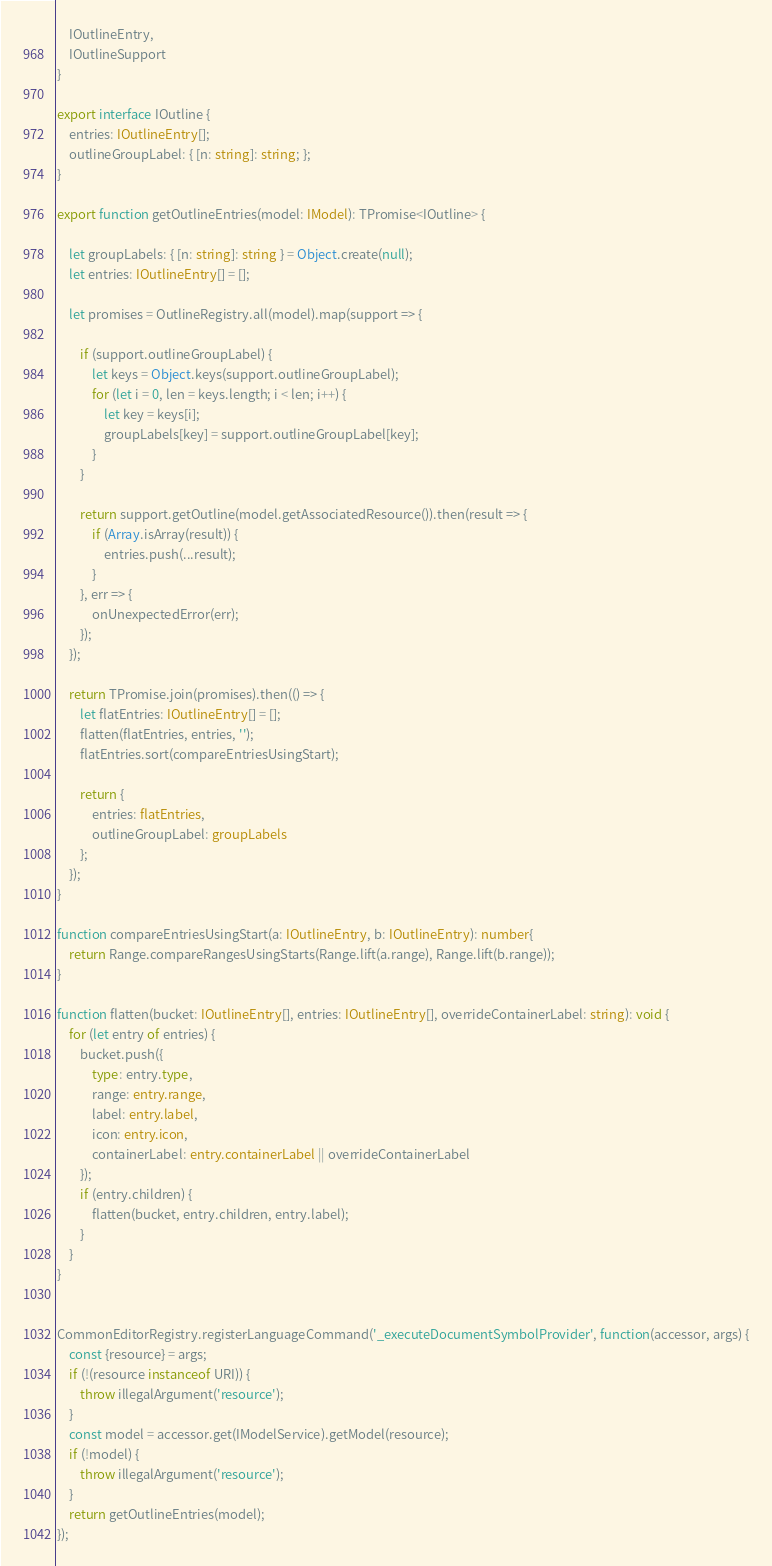<code> <loc_0><loc_0><loc_500><loc_500><_TypeScript_>	IOutlineEntry,
	IOutlineSupport
}

export interface IOutline {
	entries: IOutlineEntry[];
	outlineGroupLabel: { [n: string]: string; };
}

export function getOutlineEntries(model: IModel): TPromise<IOutline> {

	let groupLabels: { [n: string]: string } = Object.create(null);
	let entries: IOutlineEntry[] = [];

	let promises = OutlineRegistry.all(model).map(support => {

		if (support.outlineGroupLabel) {
			let keys = Object.keys(support.outlineGroupLabel);
			for (let i = 0, len = keys.length; i < len; i++) {
				let key = keys[i];
				groupLabels[key] = support.outlineGroupLabel[key];
			}
		}

		return support.getOutline(model.getAssociatedResource()).then(result => {
			if (Array.isArray(result)) {
				entries.push(...result);
			}
		}, err => {
			onUnexpectedError(err);
		});
	});

	return TPromise.join(promises).then(() => {
		let flatEntries: IOutlineEntry[] = [];
		flatten(flatEntries, entries, '');
		flatEntries.sort(compareEntriesUsingStart);

		return {
			entries: flatEntries,
			outlineGroupLabel: groupLabels
		};
	});
}

function compareEntriesUsingStart(a: IOutlineEntry, b: IOutlineEntry): number{
	return Range.compareRangesUsingStarts(Range.lift(a.range), Range.lift(b.range));
}

function flatten(bucket: IOutlineEntry[], entries: IOutlineEntry[], overrideContainerLabel: string): void {
	for (let entry of entries) {
		bucket.push({
			type: entry.type,
			range: entry.range,
			label: entry.label,
			icon: entry.icon,
			containerLabel: entry.containerLabel || overrideContainerLabel
		});
		if (entry.children) {
			flatten(bucket, entry.children, entry.label);
		}
	}
}


CommonEditorRegistry.registerLanguageCommand('_executeDocumentSymbolProvider', function(accessor, args) {
	const {resource} = args;
	if (!(resource instanceof URI)) {
		throw illegalArgument('resource');
	}
	const model = accessor.get(IModelService).getModel(resource);
	if (!model) {
		throw illegalArgument('resource');
	}
	return getOutlineEntries(model);
});</code> 